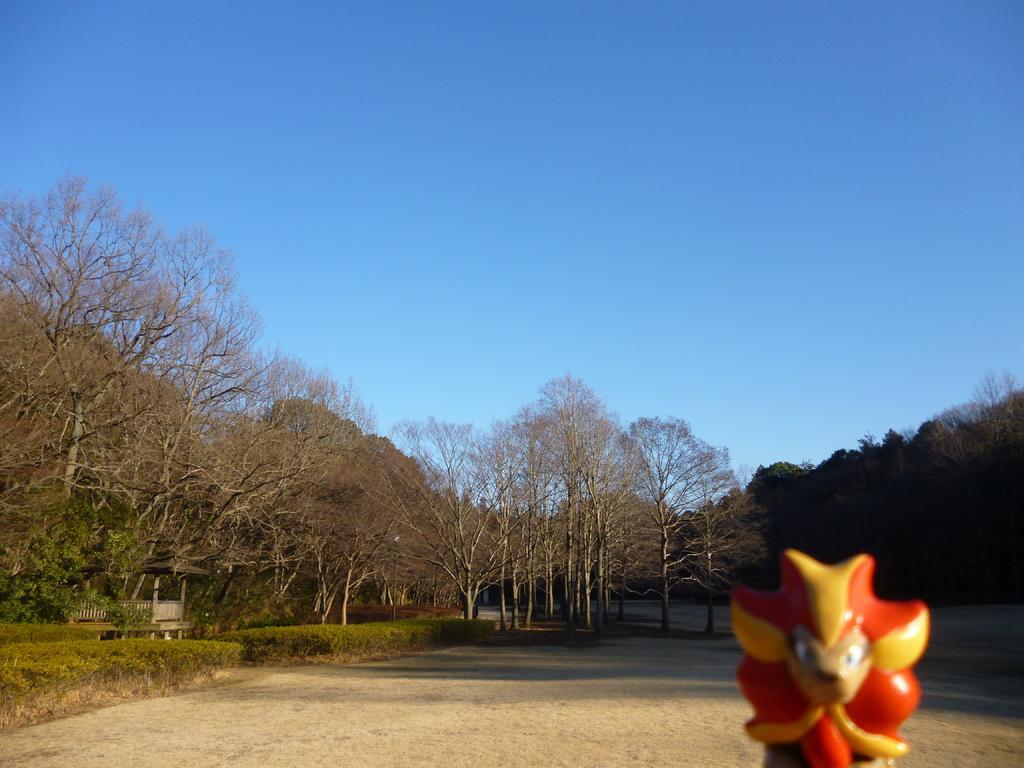Could you give a brief overview of what you see in this image? In this image we can see trees. On the left side of the image, we can see plants and shelter. At the top of the image, we can see land and an object. There is the sky at the top of the image. 